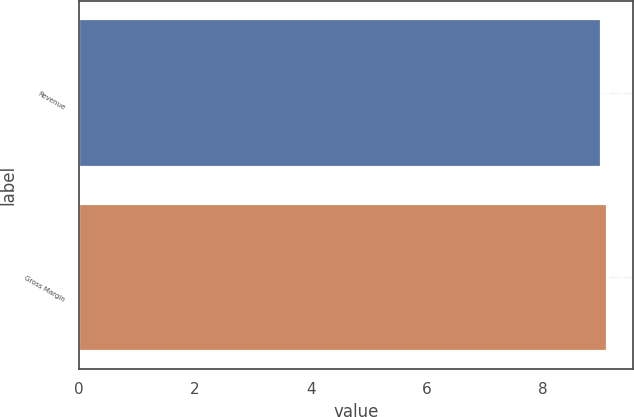Convert chart. <chart><loc_0><loc_0><loc_500><loc_500><bar_chart><fcel>Revenue<fcel>Gross Margin<nl><fcel>9<fcel>9.1<nl></chart> 